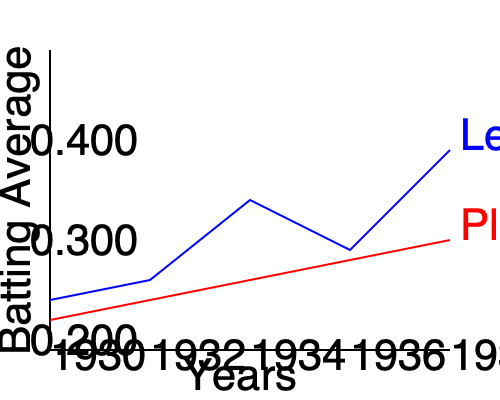Based on the graph showing batting averages from 1930 to 1938, in which year did the player's performance most closely match the league average? To determine the year when the player's performance most closely matched the league average, we need to compare the two lines (blue for league average, red for player) and find where they are closest:

1. 1930: Large gap between player and league
2. 1932: Gap is slightly smaller
3. 1934: Lines are getting closer
4. 1936: Lines are very close, almost intersecting
5. 1938: Lines have diverged again

The point where the two lines are closest represents the year when the player's batting average was most similar to the league average. This occurs in 1936, where the red line (player) and blue line (league) nearly intersect.
Answer: 1936 